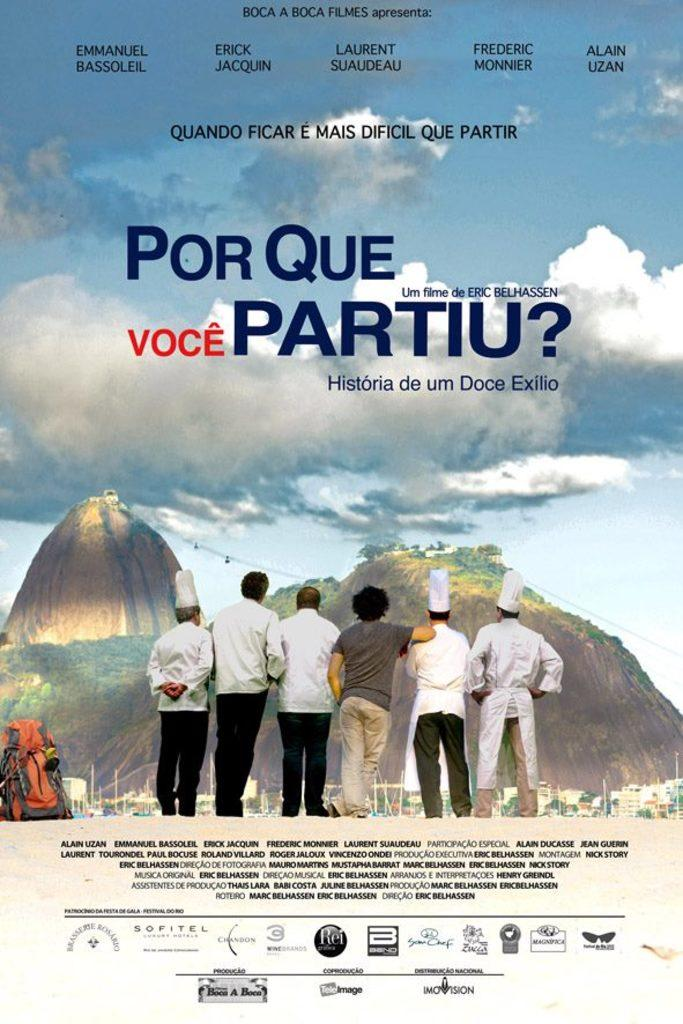<image>
Write a terse but informative summary of the picture. Poster showing some men looking at a mountain titled "Por Que Voice Partiu?". 